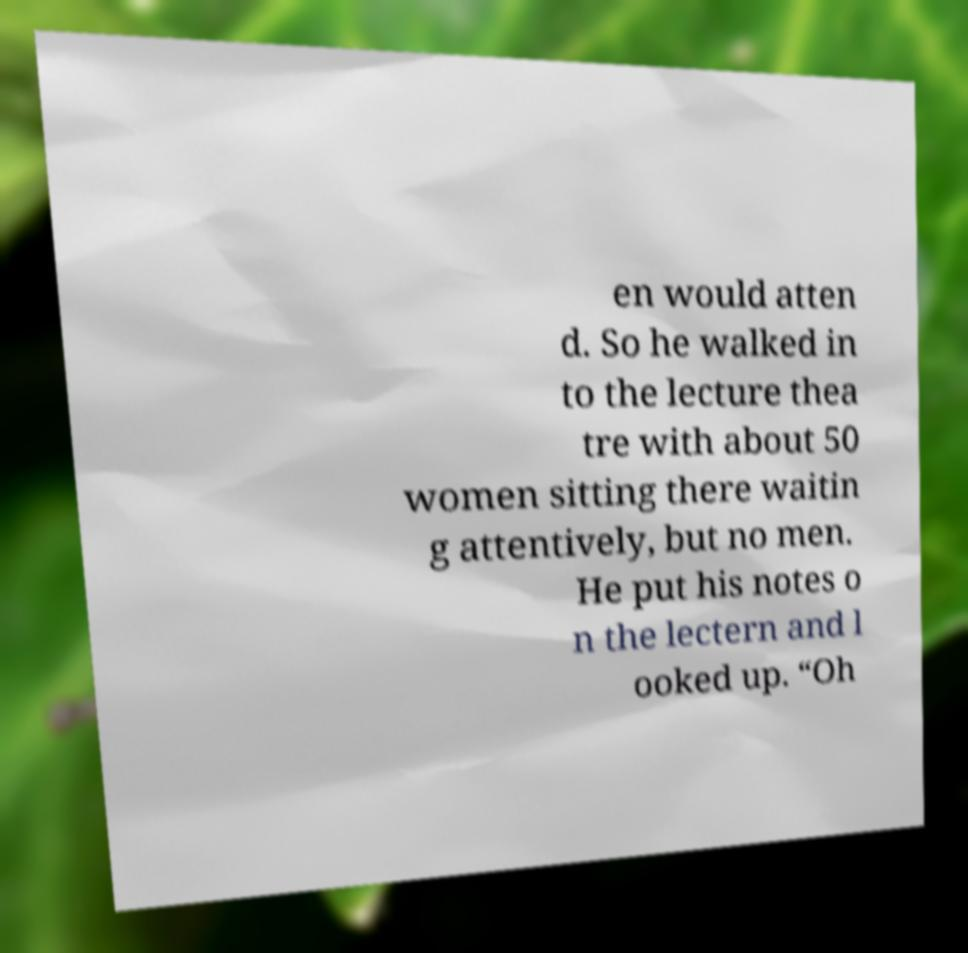Please identify and transcribe the text found in this image. en would atten d. So he walked in to the lecture thea tre with about 50 women sitting there waitin g attentively, but no men. He put his notes o n the lectern and l ooked up. “Oh 